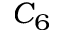<formula> <loc_0><loc_0><loc_500><loc_500>C _ { 6 }</formula> 